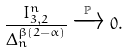<formula> <loc_0><loc_0><loc_500><loc_500>\frac { I _ { 3 , 2 } ^ { n } } { \Delta _ { n } ^ { \beta ( 2 - \alpha ) } } \xrightarrow { \mathbb { P } } 0 .</formula> 